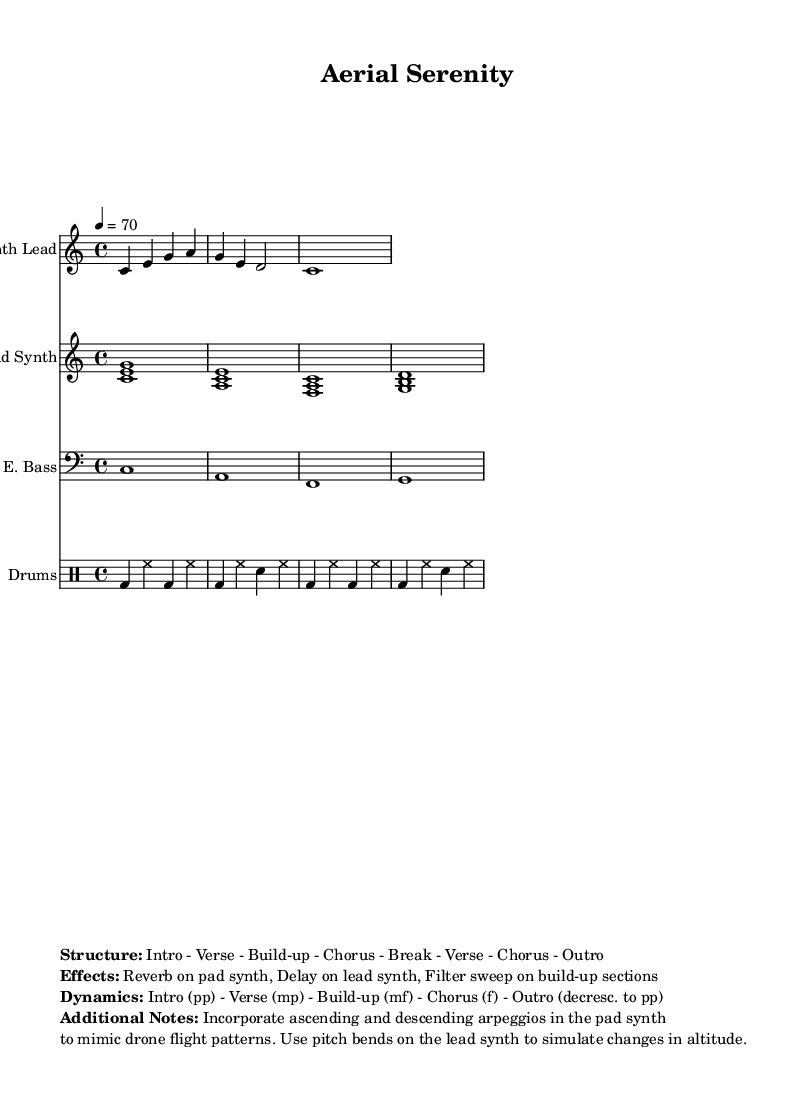What is the key signature of this music? The key signature is indicated at the beginning of the score, where it shows no sharps or flats, confirming C major.
Answer: C major What is the time signature of this piece? The time signature appears next to the key signature at the beginning, displaying a fraction format. The bottom number is 4, indicating the piece is in 4/4 time.
Answer: 4/4 What is the tempo marking of the piece? The tempo is specified in beats per minute (BPM) and is stated in the score as "4 = 70," which indicates the number of beats in a measure along with the speed.
Answer: 70 What are the dynamics at the introduction? The dynamics indicated in the score show that the introduction is marked as "pp," which means it's to be played very softly.
Answer: pp In which section does the build-up occur? The structure of the piece outlines the order of sections, and the build-up is listed as occurring after the verse and before the chorus, specified in the structure.
Answer: Build-up How does the pad synth reflect drone flight patterns? The markup section at the end describes the use of ascending and descending arpeggios to mimic drone flight patterns, indicating the intended effect.
Answer: Arpeggios What special effects are mentioned for the lead synth? The additional notes section specifies the use of pitch bends on the lead synth to simulate changes in altitude, illustrating a unique sound effect for the music.
Answer: Pitch bends 